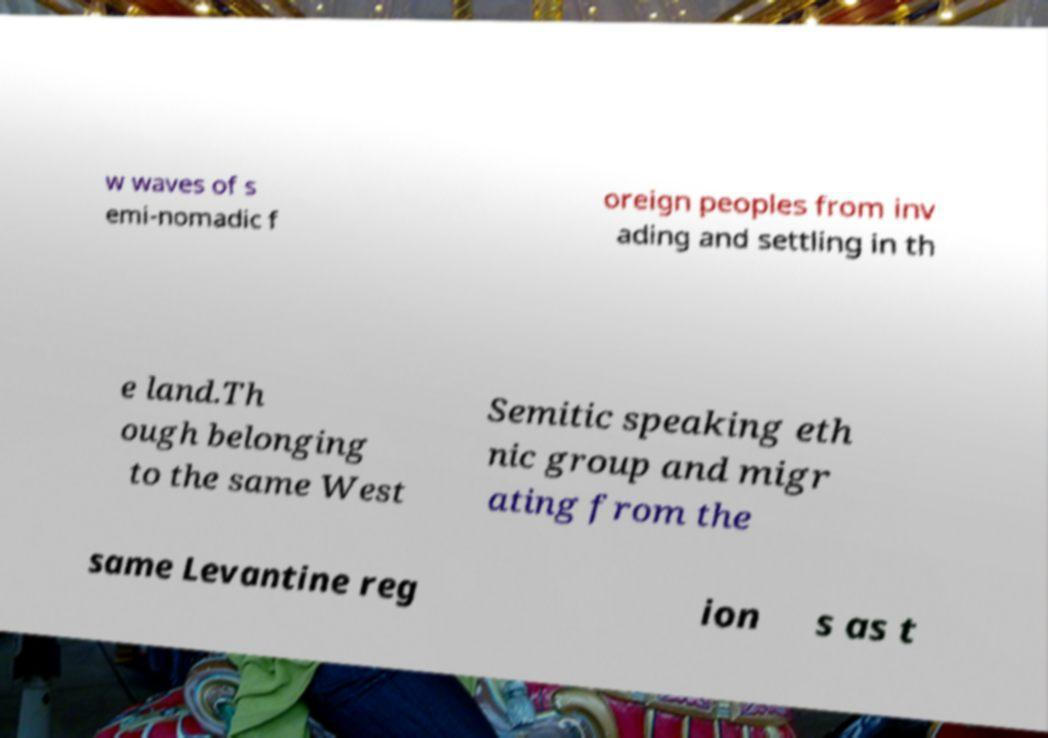Could you assist in decoding the text presented in this image and type it out clearly? w waves of s emi-nomadic f oreign peoples from inv ading and settling in th e land.Th ough belonging to the same West Semitic speaking eth nic group and migr ating from the same Levantine reg ion s as t 